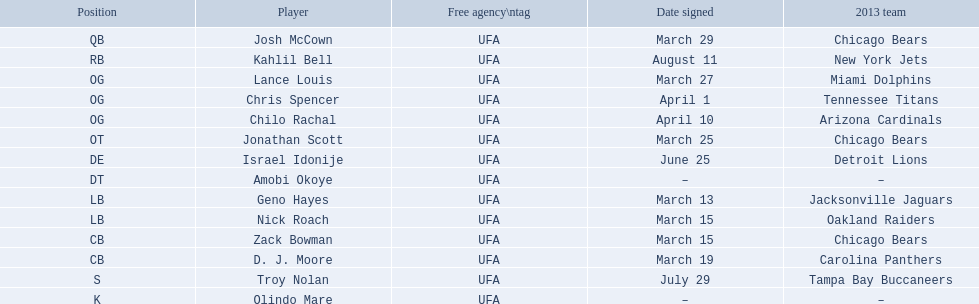Can you list the players in the 2013 chicago bears team? Josh McCown, Kahlil Bell, Lance Louis, Chris Spencer, Chilo Rachal, Jonathan Scott, Israel Idonije, Amobi Okoye, Geno Hayes, Nick Roach, Zack Bowman, D. J. Moore, Troy Nolan, Olindo Mare. When was nick roach signed to the team? March 15. Is there any other date with similar importance? March 15. Which player was signed on that particular day? Zack Bowman. 